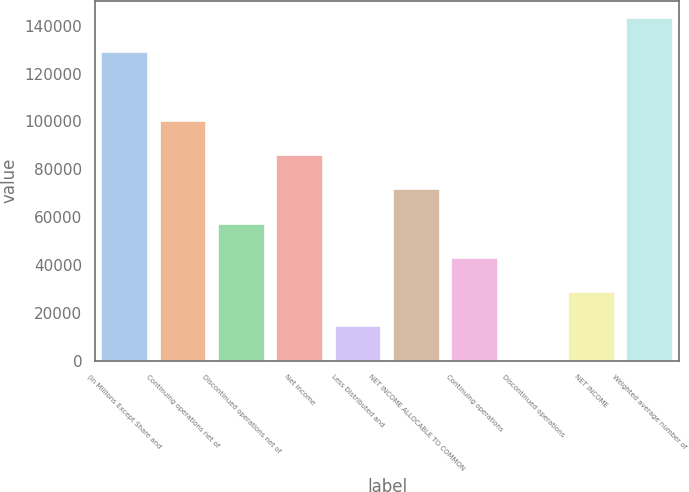Convert chart. <chart><loc_0><loc_0><loc_500><loc_500><bar_chart><fcel>(in Millions Except Share and<fcel>Continuing operations net of<fcel>Discontinued operations net of<fcel>Net income<fcel>Less Distributed and<fcel>NET INCOME ALLOCABLE TO COMMON<fcel>Continuing operations<fcel>Discontinued operations<fcel>NET INCOME<fcel>Weighted average number of<nl><fcel>128977<fcel>100316<fcel>57323.3<fcel>85984.9<fcel>14331<fcel>71654.1<fcel>42992.6<fcel>0.22<fcel>28661.8<fcel>143308<nl></chart> 